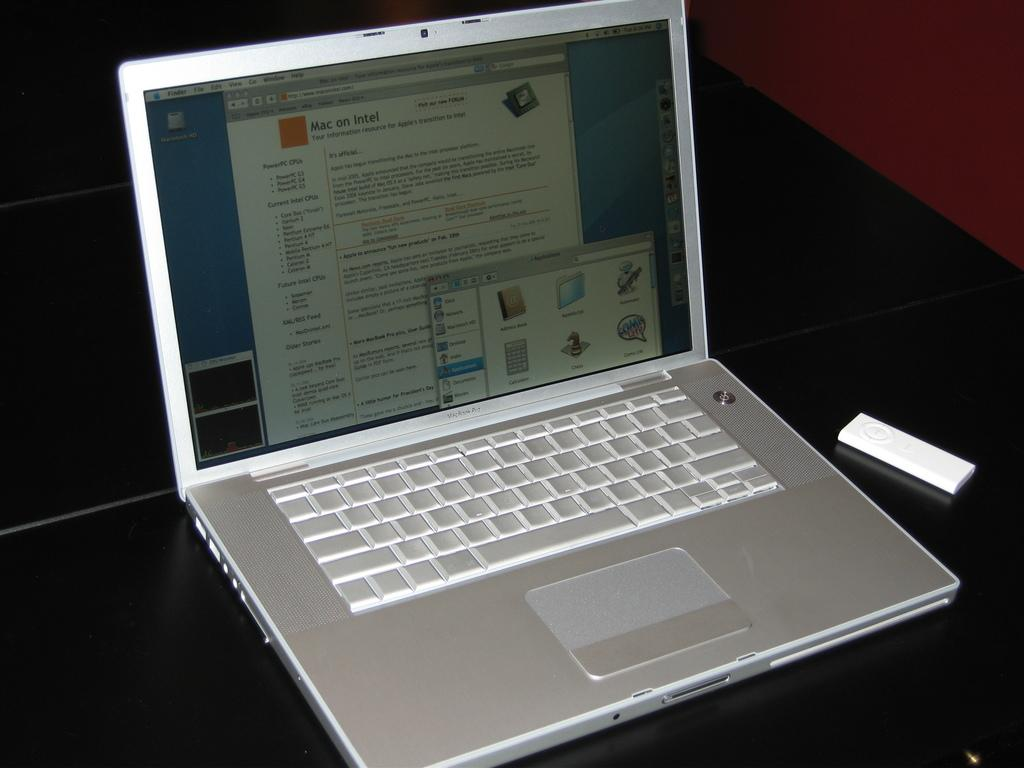<image>
Render a clear and concise summary of the photo. A Macbook Pro displays a website talking about Mac on Intel. 